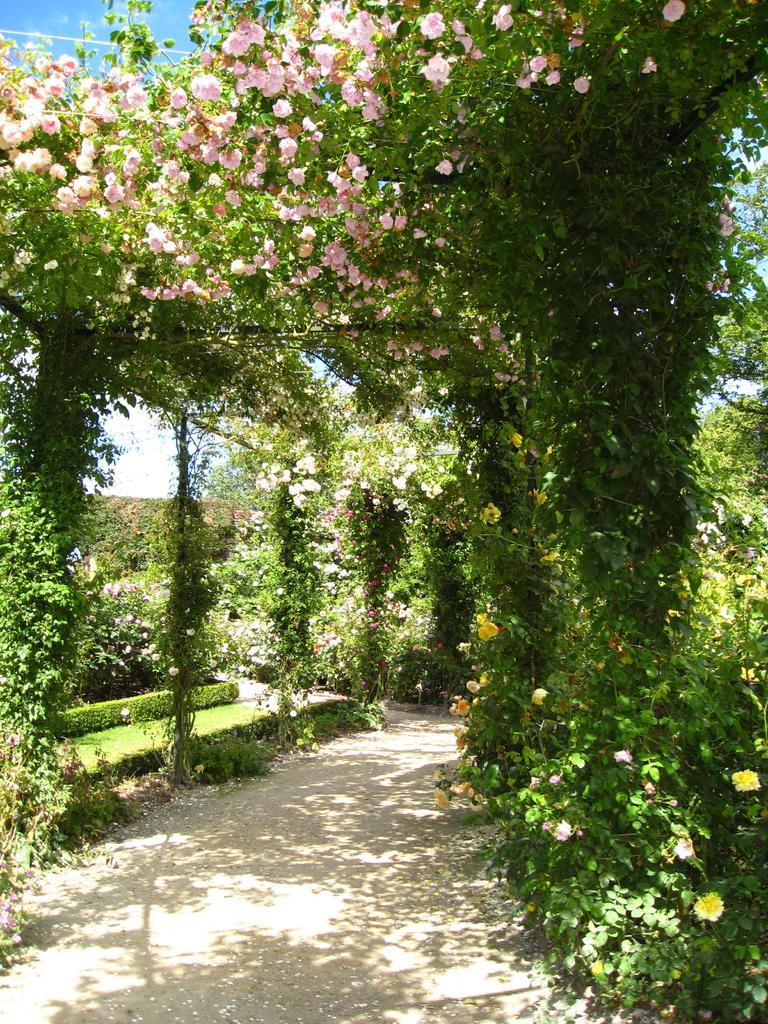Could you give a brief overview of what you see in this image? In this picture I can see some flowers on the vine plants. In the back I can see the trees, plants and grass. In the top left corner I can see the sky. 